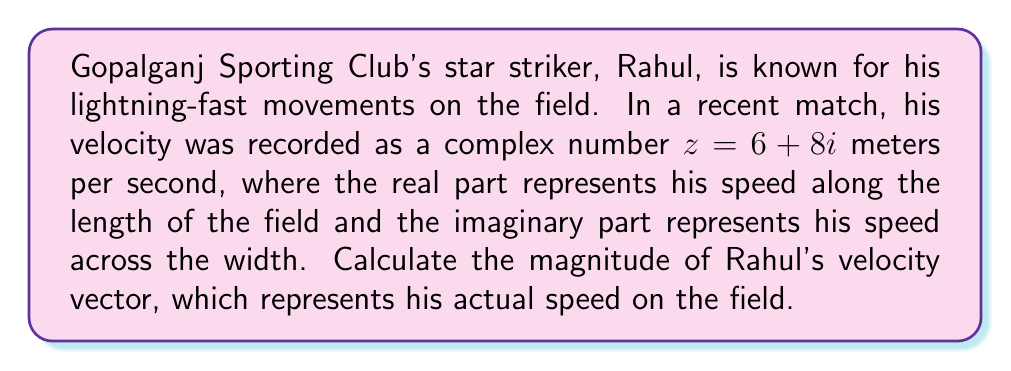What is the answer to this math problem? To find the magnitude of a complex number $z = a + bi$, we use the formula:

$$|z| = \sqrt{a^2 + b^2}$$

Where $|z|$ represents the magnitude of the complex number.

For Rahul's velocity $z = 6 + 8i$:
$a = 6$ (real part)
$b = 8$ (imaginary part)

Substituting these values into the formula:

$$|z| = \sqrt{6^2 + 8^2}$$

$$|z| = \sqrt{36 + 64}$$

$$|z| = \sqrt{100}$$

$$|z| = 10$$

Therefore, the magnitude of Rahul's velocity vector is 10 meters per second.

This result represents Rahul's actual speed on the field, combining his movement along both the length and width of the pitch.
Answer: $10$ meters per second 